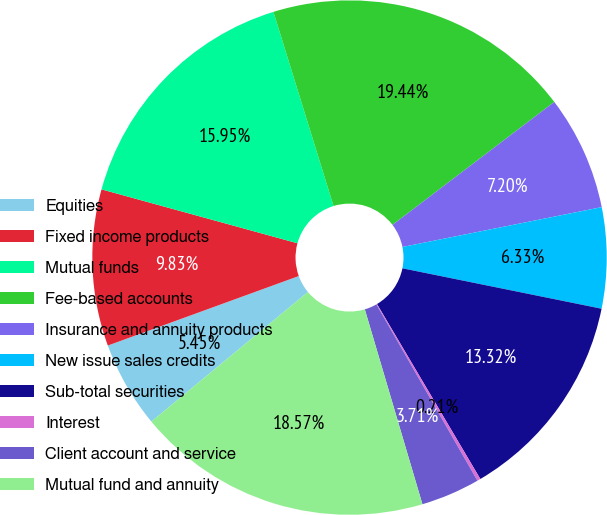Convert chart. <chart><loc_0><loc_0><loc_500><loc_500><pie_chart><fcel>Equities<fcel>Fixed income products<fcel>Mutual funds<fcel>Fee-based accounts<fcel>Insurance and annuity products<fcel>New issue sales credits<fcel>Sub-total securities<fcel>Interest<fcel>Client account and service<fcel>Mutual fund and annuity<nl><fcel>5.45%<fcel>9.83%<fcel>15.95%<fcel>19.44%<fcel>7.2%<fcel>6.33%<fcel>13.32%<fcel>0.21%<fcel>3.71%<fcel>18.57%<nl></chart> 